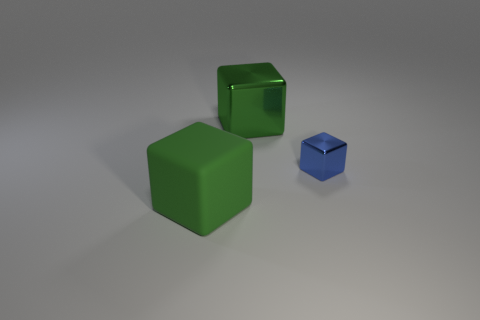Add 3 yellow matte blocks. How many objects exist? 6 Subtract 0 brown blocks. How many objects are left? 3 Subtract all gray metallic things. Subtract all green metal things. How many objects are left? 2 Add 2 small blocks. How many small blocks are left? 3 Add 1 large shiny blocks. How many large shiny blocks exist? 2 